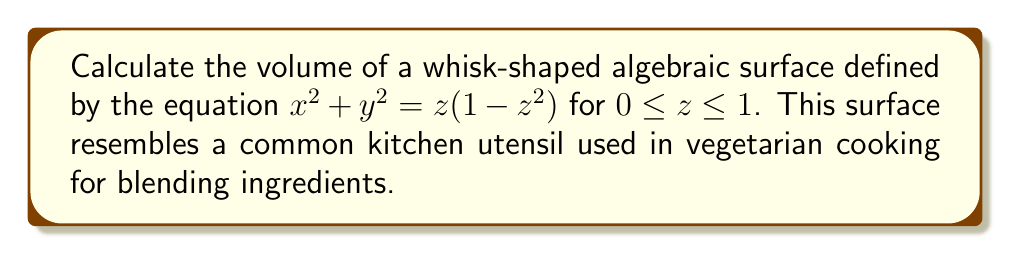Help me with this question. To calculate the volume of this whisk-shaped surface, we'll use the method of cylindrical shells:

1) First, we need to express $x$ and $y$ in terms of $z$:
   $x^2 + y^2 = z(1-z^2)$
   $r^2 = z(1-z^2)$, where $r$ is the radius of each circular cross-section

2) The volume of a cylindrical shell is given by:
   $dV = 2\pi r h dr$, where $h$ is the height of the shell

3) In our case, $r = \sqrt{z(1-z^2)}$ and $h = dz$

4) We need to integrate this from $z = 0$ to $z = 1$:
   $$V = \int_0^1 2\pi r^2 dz = 2\pi \int_0^1 z(1-z^2) dz$$

5) Expanding the integrand:
   $$V = 2\pi \int_0^1 (z - z^3) dz$$

6) Integrating:
   $$V = 2\pi \left[\frac{z^2}{2} - \frac{z^4}{4}\right]_0^1$$

7) Evaluating the integral:
   $$V = 2\pi \left(\frac{1}{2} - \frac{1}{4}\right) - 2\pi(0) = 2\pi \cdot \frac{1}{4} = \frac{\pi}{2}$$

Therefore, the volume of the whisk-shaped surface is $\frac{\pi}{2}$ cubic units.
Answer: $\frac{\pi}{2}$ cubic units 